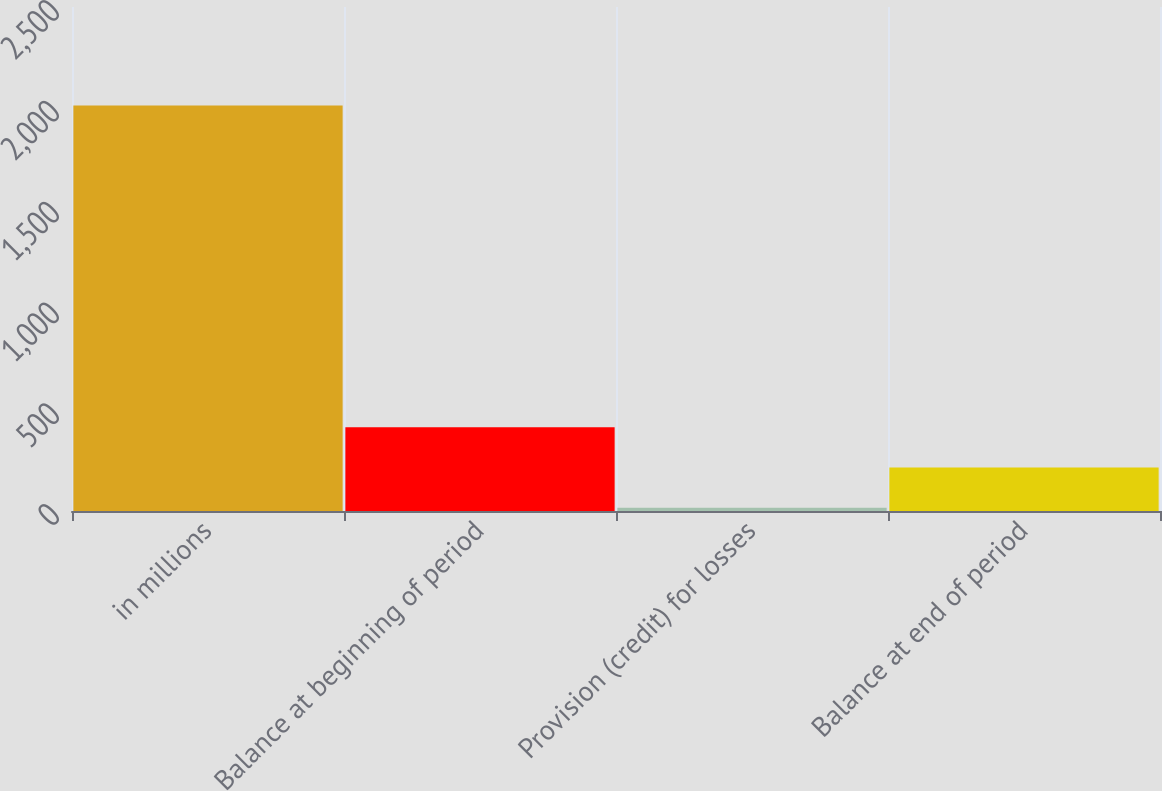Convert chart. <chart><loc_0><loc_0><loc_500><loc_500><bar_chart><fcel>in millions<fcel>Balance at beginning of period<fcel>Provision (credit) for losses<fcel>Balance at end of period<nl><fcel>2012<fcel>415.2<fcel>16<fcel>215.6<nl></chart> 